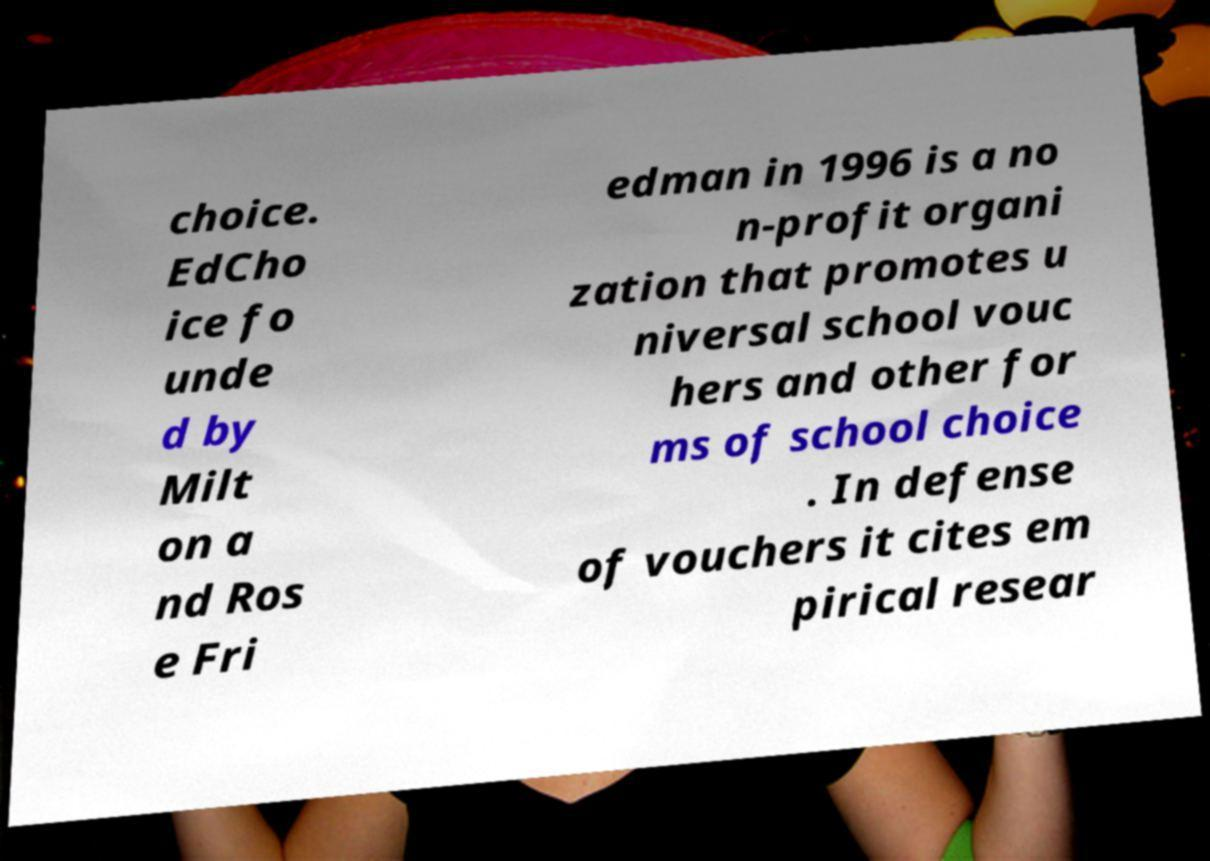Can you read and provide the text displayed in the image?This photo seems to have some interesting text. Can you extract and type it out for me? choice. EdCho ice fo unde d by Milt on a nd Ros e Fri edman in 1996 is a no n-profit organi zation that promotes u niversal school vouc hers and other for ms of school choice . In defense of vouchers it cites em pirical resear 